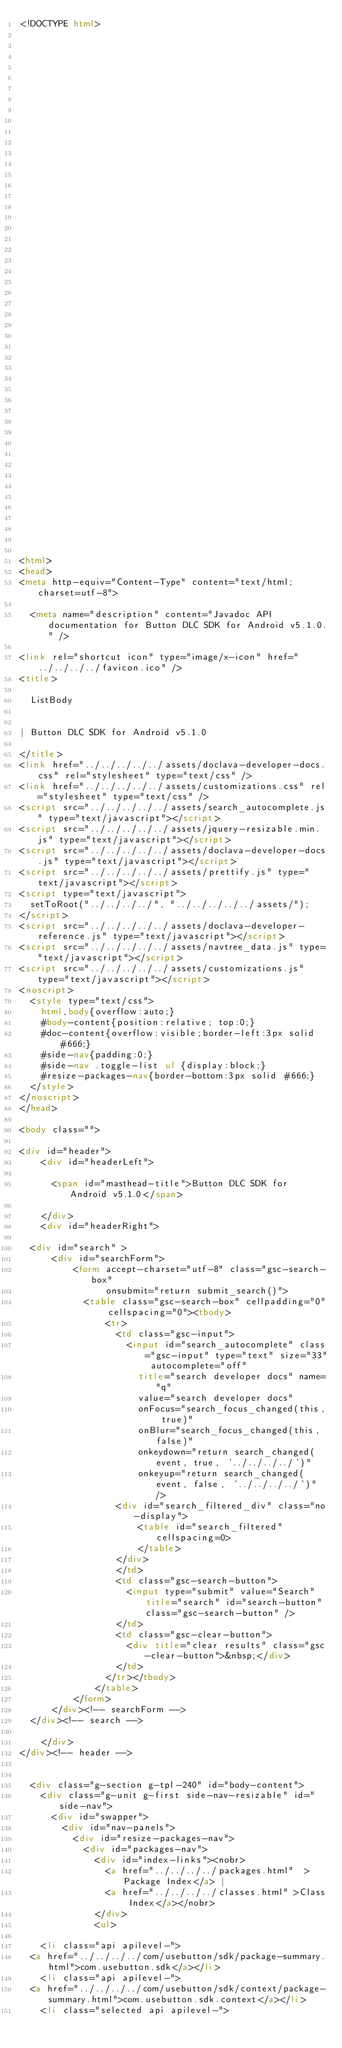Convert code to text. <code><loc_0><loc_0><loc_500><loc_500><_HTML_><!DOCTYPE html>

















































<html>
<head>
<meta http-equiv="Content-Type" content="text/html; charset=utf-8">

  <meta name="description" content="Javadoc API documentation for Button DLC SDK for Android v5.1.0." />

<link rel="shortcut icon" type="image/x-icon" href="../../../../favicon.ico" />
<title>

  ListBody


| Button DLC SDK for Android v5.1.0

</title>
<link href="../../../../../assets/doclava-developer-docs.css" rel="stylesheet" type="text/css" />
<link href="../../../../../assets/customizations.css" rel="stylesheet" type="text/css" />
<script src="../../../../../assets/search_autocomplete.js" type="text/javascript"></script>
<script src="../../../../../assets/jquery-resizable.min.js" type="text/javascript"></script>
<script src="../../../../../assets/doclava-developer-docs.js" type="text/javascript"></script>
<script src="../../../../../assets/prettify.js" type="text/javascript"></script>
<script type="text/javascript">
  setToRoot("../../../../", "../../../../../assets/");
</script>
<script src="../../../../../assets/doclava-developer-reference.js" type="text/javascript"></script>
<script src="../../../../../assets/navtree_data.js" type="text/javascript"></script>
<script src="../../../../../assets/customizations.js" type="text/javascript"></script>
<noscript>
  <style type="text/css">
    html,body{overflow:auto;}
    #body-content{position:relative; top:0;}
    #doc-content{overflow:visible;border-left:3px solid #666;}
    #side-nav{padding:0;}
    #side-nav .toggle-list ul {display:block;}
    #resize-packages-nav{border-bottom:3px solid #666;}
  </style>
</noscript>
</head>

<body class="">

<div id="header">
    <div id="headerLeft">
    
      <span id="masthead-title">Button DLC SDK for Android v5.1.0</span>
    
    </div>
    <div id="headerRight">
      
  <div id="search" >
      <div id="searchForm">
          <form accept-charset="utf-8" class="gsc-search-box" 
                onsubmit="return submit_search()">
            <table class="gsc-search-box" cellpadding="0" cellspacing="0"><tbody>
                <tr>
                  <td class="gsc-input">
                    <input id="search_autocomplete" class="gsc-input" type="text" size="33" autocomplete="off"
                      title="search developer docs" name="q"
                      value="search developer docs"
                      onFocus="search_focus_changed(this, true)"
                      onBlur="search_focus_changed(this, false)"
                      onkeydown="return search_changed(event, true, '../../../../')"
                      onkeyup="return search_changed(event, false, '../../../../')" />
                  <div id="search_filtered_div" class="no-display">
                      <table id="search_filtered" cellspacing=0>
                      </table>
                  </div>
                  </td>
                  <td class="gsc-search-button">
                    <input type="submit" value="Search" title="search" id="search-button" class="gsc-search-button" />
                  </td>
                  <td class="gsc-clear-button">
                    <div title="clear results" class="gsc-clear-button">&nbsp;</div>
                  </td>
                </tr></tbody>
              </table>
          </form>
      </div><!-- searchForm -->
  </div><!-- search -->
      
    </div>
</div><!-- header -->


  <div class="g-section g-tpl-240" id="body-content">
    <div class="g-unit g-first side-nav-resizable" id="side-nav">
      <div id="swapper">
        <div id="nav-panels">
          <div id="resize-packages-nav">
            <div id="packages-nav">
              <div id="index-links"><nobr>
                <a href="../../../../packages.html"  >Package Index</a> | 
                <a href="../../../../classes.html" >Class Index</a></nobr>
              </div>
              <ul>
                
    <li class="api apilevel-">
  <a href="../../../../com/usebutton/sdk/package-summary.html">com.usebutton.sdk</a></li>
    <li class="api apilevel-">
  <a href="../../../../com/usebutton/sdk/context/package-summary.html">com.usebutton.sdk.context</a></li>
    <li class="selected api apilevel-"></code> 